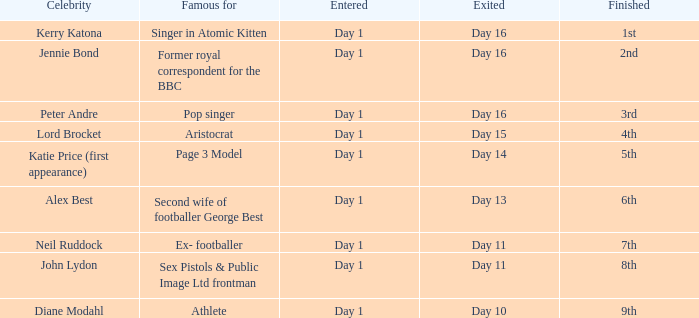Identify the completed for departed day 13 6th. 